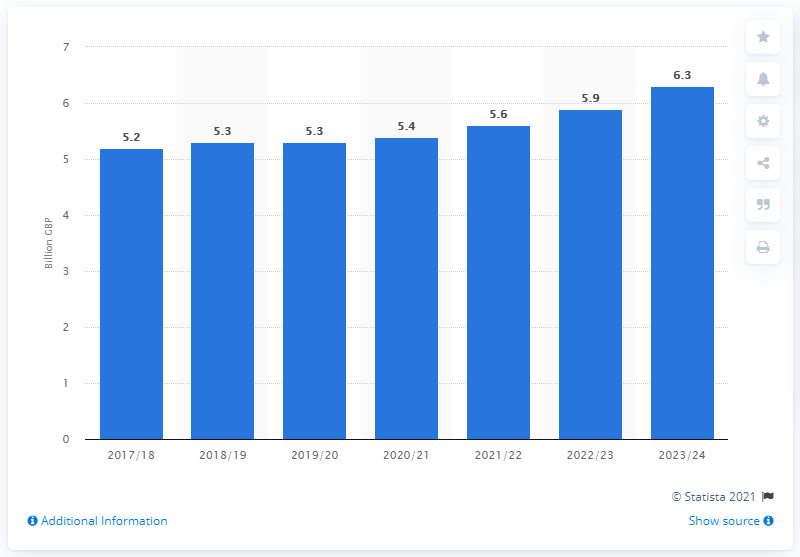Draw attention to some important aspects in this diagram. The expected increase in inheritance tax in 2023/24 is 6.3%. The government anticipates receiving approximately 5.2 billion pounds in inheritance tax revenue for the 2017/18 fiscal year. 